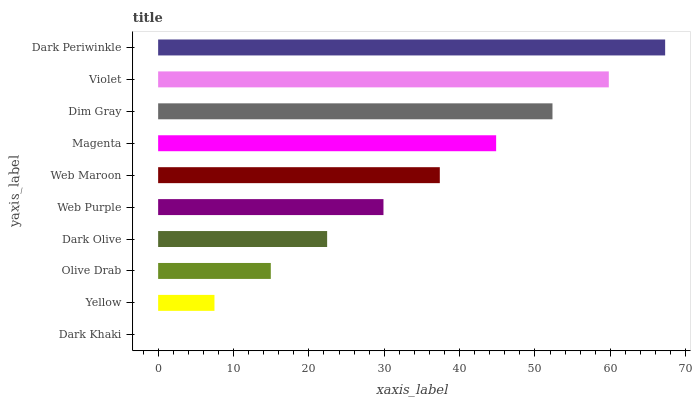Is Dark Khaki the minimum?
Answer yes or no. Yes. Is Dark Periwinkle the maximum?
Answer yes or no. Yes. Is Yellow the minimum?
Answer yes or no. No. Is Yellow the maximum?
Answer yes or no. No. Is Yellow greater than Dark Khaki?
Answer yes or no. Yes. Is Dark Khaki less than Yellow?
Answer yes or no. Yes. Is Dark Khaki greater than Yellow?
Answer yes or no. No. Is Yellow less than Dark Khaki?
Answer yes or no. No. Is Web Maroon the high median?
Answer yes or no. Yes. Is Web Purple the low median?
Answer yes or no. Yes. Is Yellow the high median?
Answer yes or no. No. Is Olive Drab the low median?
Answer yes or no. No. 